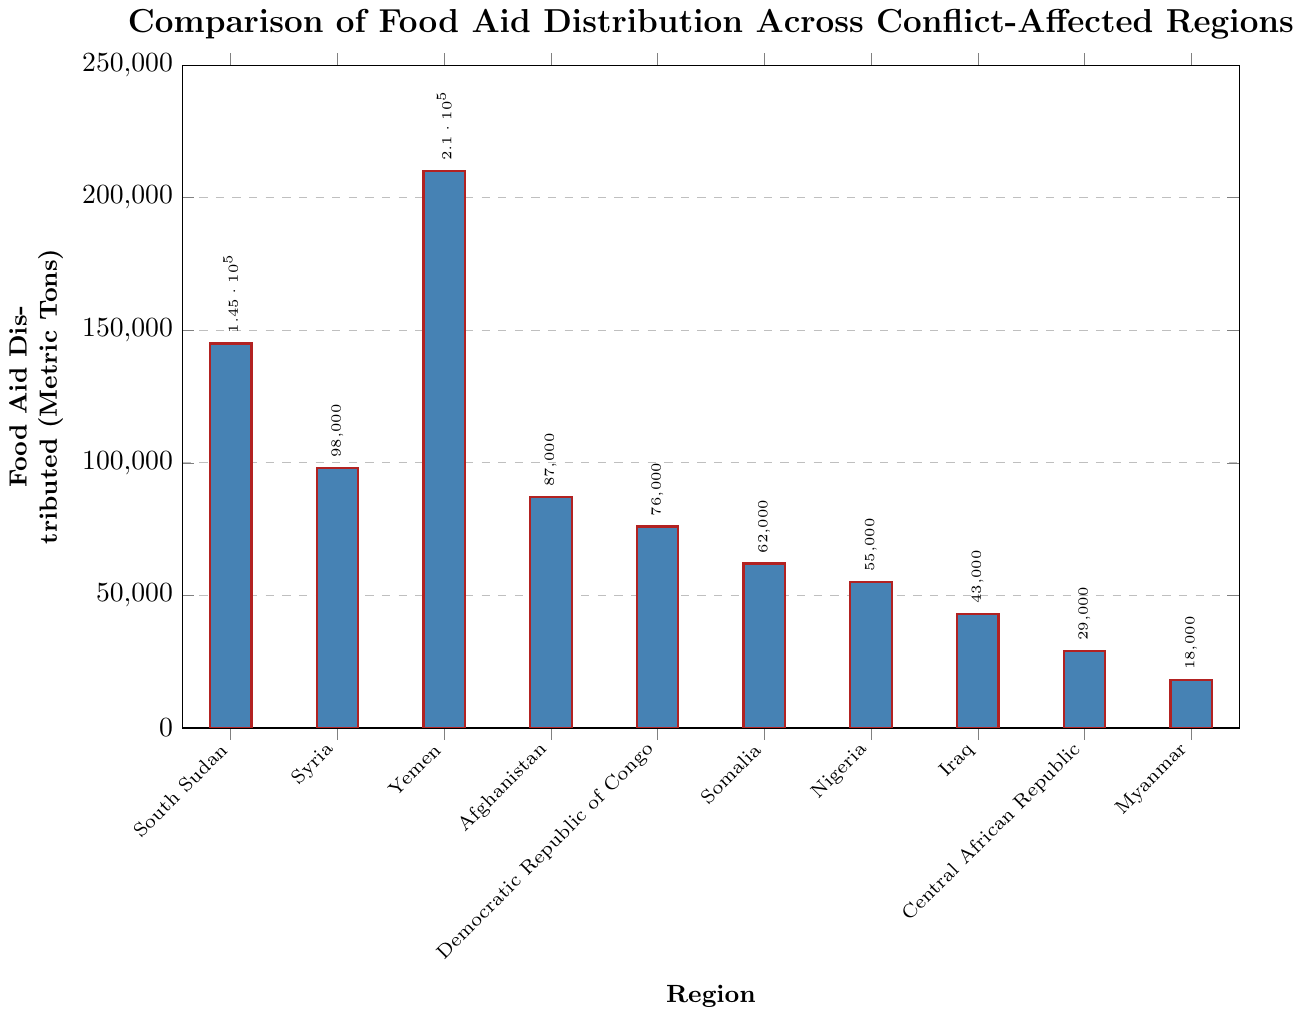What's the region with the highest amount of food aid distributed? The bar chart shows the food aid distributed in metric tons to various regions. The tallest bar represents Yemen.
Answer: Yemen Which two regions have the smallest amount of food aid distributed? The bars representing Myanmar and Central African Republic are the shortest in the chart.
Answer: Myanmar and Central African Republic What is the total food aid distributed to South Sudan and Syria? According to the chart, South Sudan received 145,000 metric tons, and Syria received 98,000 metric tons. Adding these together: 145,000 + 98,000 = 243,000.
Answer: 243,000 metric tons How much more food aid has Yemen received compared to Afghanistan? Yemen received 210,000 metric tons, while Afghanistan received 87,000 metric tons. The difference is 210,000 - 87,000 = 123,000.
Answer: 123,000 metric tons What is the combined food aid distributed to Democratic Republic of Congo, Somalia, and Nigeria? The amounts are 76,000 (DRC), 62,000 (Somalia), and 55,000 (Nigeria). Summing these: 76,000 + 62,000 + 55,000 = 193,000.
Answer: 193,000 metric tons Which region received more food aid: Iraq or Myanmar? According to the chart, Iraq received 43,000 metric tons and Myanmar received 18,000 metric tons. Iraq received more.
Answer: Iraq How much more food aid has South Sudan received compared to Somalia? South Sudan received 145,000 metric tons, while Somalia received 62,000 metric tons. The difference is 145,000 - 62,000 = 83,000.
Answer: 83,000 metric tons What's the difference in food aid distributed between South Sudan and Yemen? South Sudan received 145,000 metric tons, Yemen received 210,000 metric tons. The difference is 210,000 - 145,000 = 65,000.
Answer: 65,000 metric tons What is the average amount of food aid distributed across all the listed regions? The total food aid across all regions is the sum of all values: 145,000 + 98,000 + 210,000 + 87,000 + 76,000 + 62,000 + 55,000 + 43,000 + 29,000 + 18,000 = 823,000. There are 10 regions: 823,000 / 10 = 82,300.
Answer: 82,300 metric tons Which region received approximately half of the food aid given to Syria? Syria received 98,000 metric tons. Half of 98,000 is 49,000. The closest region to this value is Iraq with 43,000 metric tons.
Answer: Iraq 